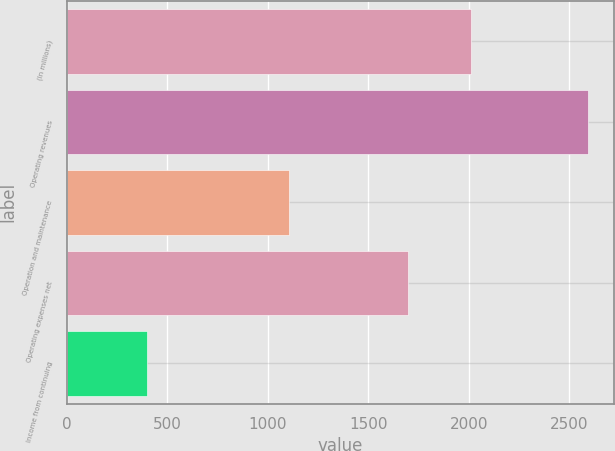Convert chart to OTSL. <chart><loc_0><loc_0><loc_500><loc_500><bar_chart><fcel>(In millions)<fcel>Operating revenues<fcel>Operation and maintenance<fcel>Operating expenses net<fcel>Income from continuing<nl><fcel>2013<fcel>2594<fcel>1105<fcel>1700<fcel>400<nl></chart> 